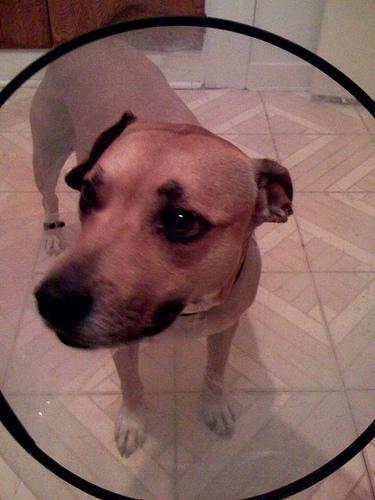What animal is this?
Quick response, please. Dog. What breed of dog does this look like?
Write a very short answer. Lab. Where is the dog standing in the pic?
Concise answer only. On floor. What color is the floor?
Concise answer only. White. 